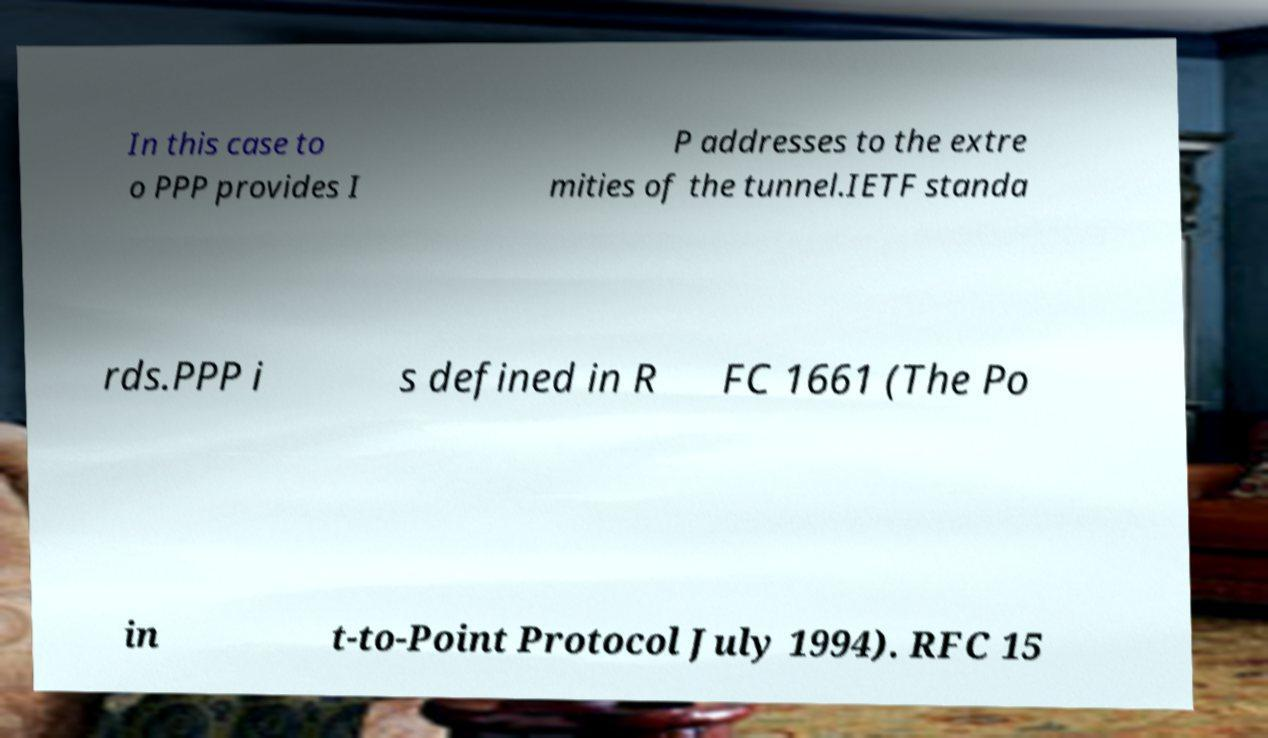Please identify and transcribe the text found in this image. In this case to o PPP provides I P addresses to the extre mities of the tunnel.IETF standa rds.PPP i s defined in R FC 1661 (The Po in t-to-Point Protocol July 1994). RFC 15 